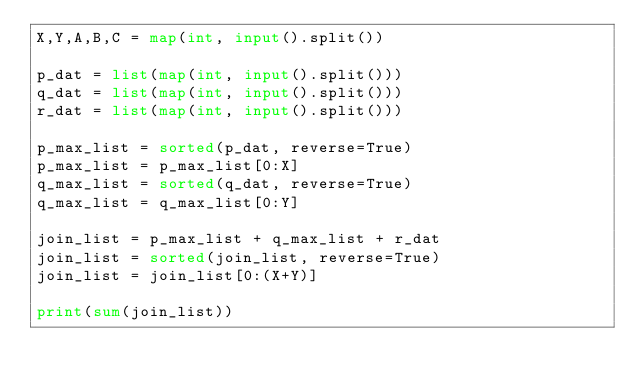Convert code to text. <code><loc_0><loc_0><loc_500><loc_500><_Python_>X,Y,A,B,C = map(int, input().split())

p_dat = list(map(int, input().split()))
q_dat = list(map(int, input().split()))
r_dat = list(map(int, input().split()))

p_max_list = sorted(p_dat, reverse=True)
p_max_list = p_max_list[0:X]
q_max_list = sorted(q_dat, reverse=True)
q_max_list = q_max_list[0:Y]

join_list = p_max_list + q_max_list + r_dat
join_list = sorted(join_list, reverse=True)
join_list = join_list[0:(X+Y)]

print(sum(join_list))</code> 